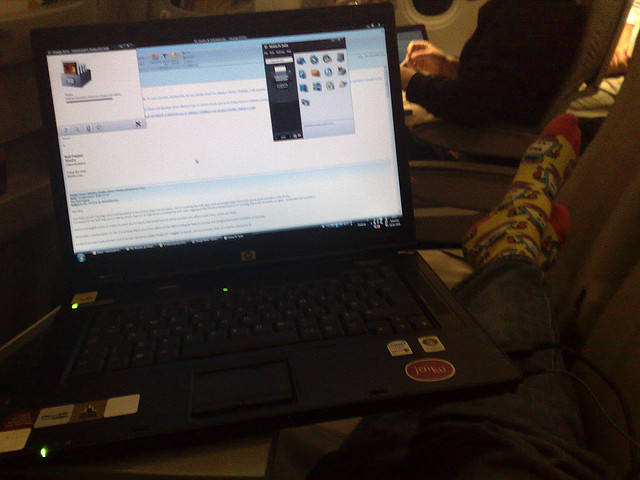<image>What part of the computer is the girl currently touching? I am not sure what part of the computer the girl is currently touching. It could be the keyboard or the bottom side. What website is being used? I don't know what website is being used. It can be Facebook, Google, an email program such as Outlook, or some kind of storage site. What are the two words on the blue strip? I am not sure about the words on the blue strip. It could be 'stop now', 'windows 10' or 'mail full'. What part of the computer is the girl currently touching? The girl is currently touching the keyboard of the computer. What website is being used? I don't know what website is being used. It can be seen 'facebook', 'google', 'outlook' or 'yahoocom'. What are the two words on the blue strip? I am not sure what are the two words on the blue strip. It can be seen 'stop now', 'cannot tell', 'gobbledygook', 'nothing', 'windows 10', 'blurry' or 'mail full'. 